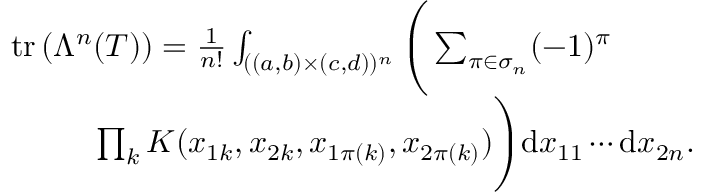<formula> <loc_0><loc_0><loc_500><loc_500>\begin{array} { r l } & { t r \left ( \Lambda ^ { n } ( { T } ) \right ) = \frac { 1 } { n ! } \int _ { ( ( a , b ) \times ( c , d ) ) ^ { n } } \left ( \sum _ { \pi \in \sigma _ { n } } ( - 1 ) ^ { \pi } } \\ & { \prod _ { k } K ( x _ { 1 k } , x _ { 2 k } , x _ { 1 \pi ( k ) } , x _ { 2 \pi ( k ) } ) \right ) d x _ { 1 1 } \cdots d x _ { 2 n } . } \end{array}</formula> 